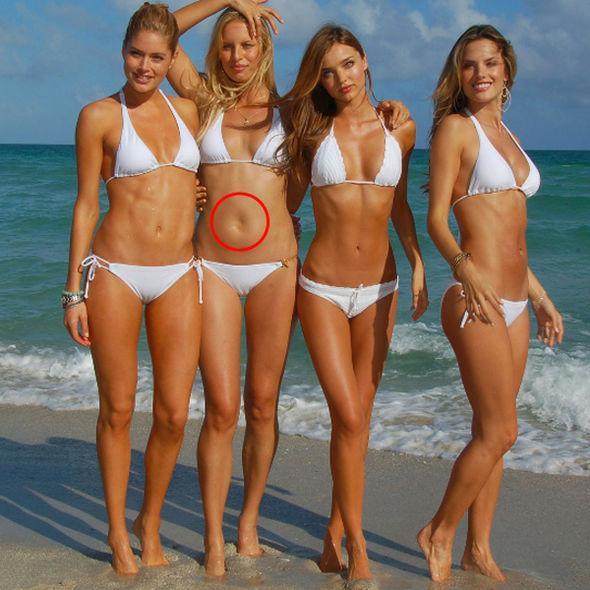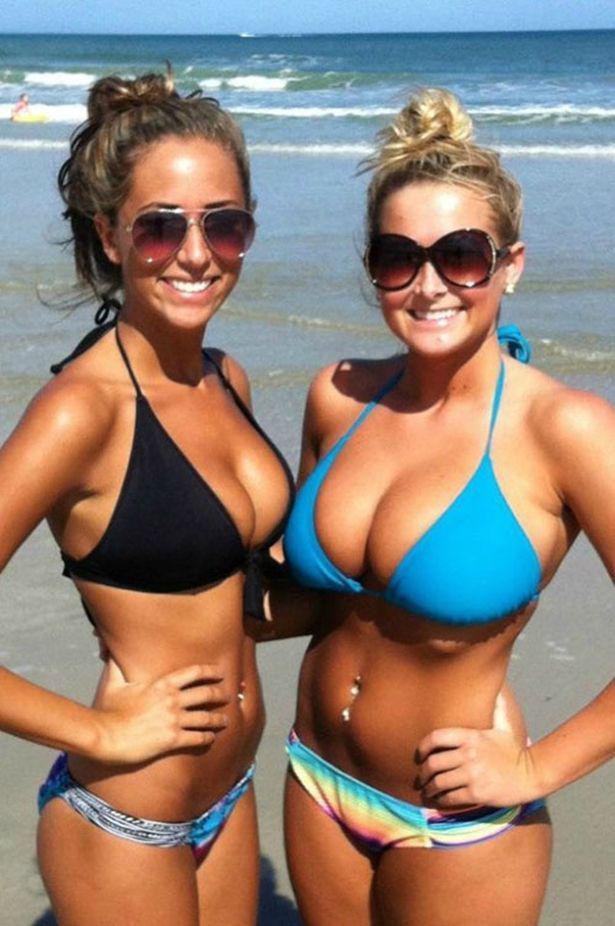The first image is the image on the left, the second image is the image on the right. Given the left and right images, does the statement "All of the models are shown from the front, and are wearing tops that can be seen to loop around the neck." hold true? Answer yes or no. Yes. The first image is the image on the left, the second image is the image on the right. For the images shown, is this caption "The woman on the left has on a light blue bikini." true? Answer yes or no. No. 